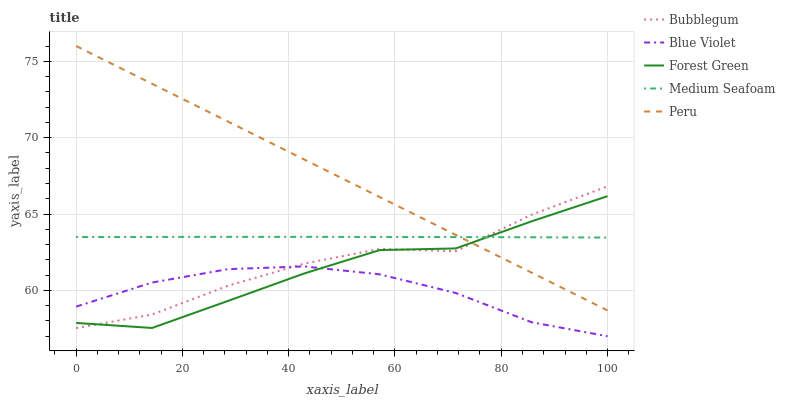Does Blue Violet have the minimum area under the curve?
Answer yes or no. Yes. Does Peru have the maximum area under the curve?
Answer yes or no. Yes. Does Forest Green have the minimum area under the curve?
Answer yes or no. No. Does Forest Green have the maximum area under the curve?
Answer yes or no. No. Is Peru the smoothest?
Answer yes or no. Yes. Is Bubblegum the roughest?
Answer yes or no. Yes. Is Forest Green the smoothest?
Answer yes or no. No. Is Forest Green the roughest?
Answer yes or no. No. Does Forest Green have the lowest value?
Answer yes or no. No. Does Forest Green have the highest value?
Answer yes or no. No. Is Blue Violet less than Peru?
Answer yes or no. Yes. Is Peru greater than Blue Violet?
Answer yes or no. Yes. Does Blue Violet intersect Peru?
Answer yes or no. No. 